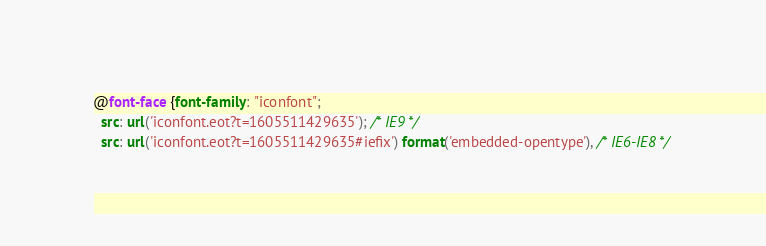Convert code to text. <code><loc_0><loc_0><loc_500><loc_500><_CSS_>@font-face {font-family: "iconfont";
  src: url('iconfont.eot?t=1605511429635'); /* IE9 */
  src: url('iconfont.eot?t=1605511429635#iefix') format('embedded-opentype'), /* IE6-IE8 */</code> 